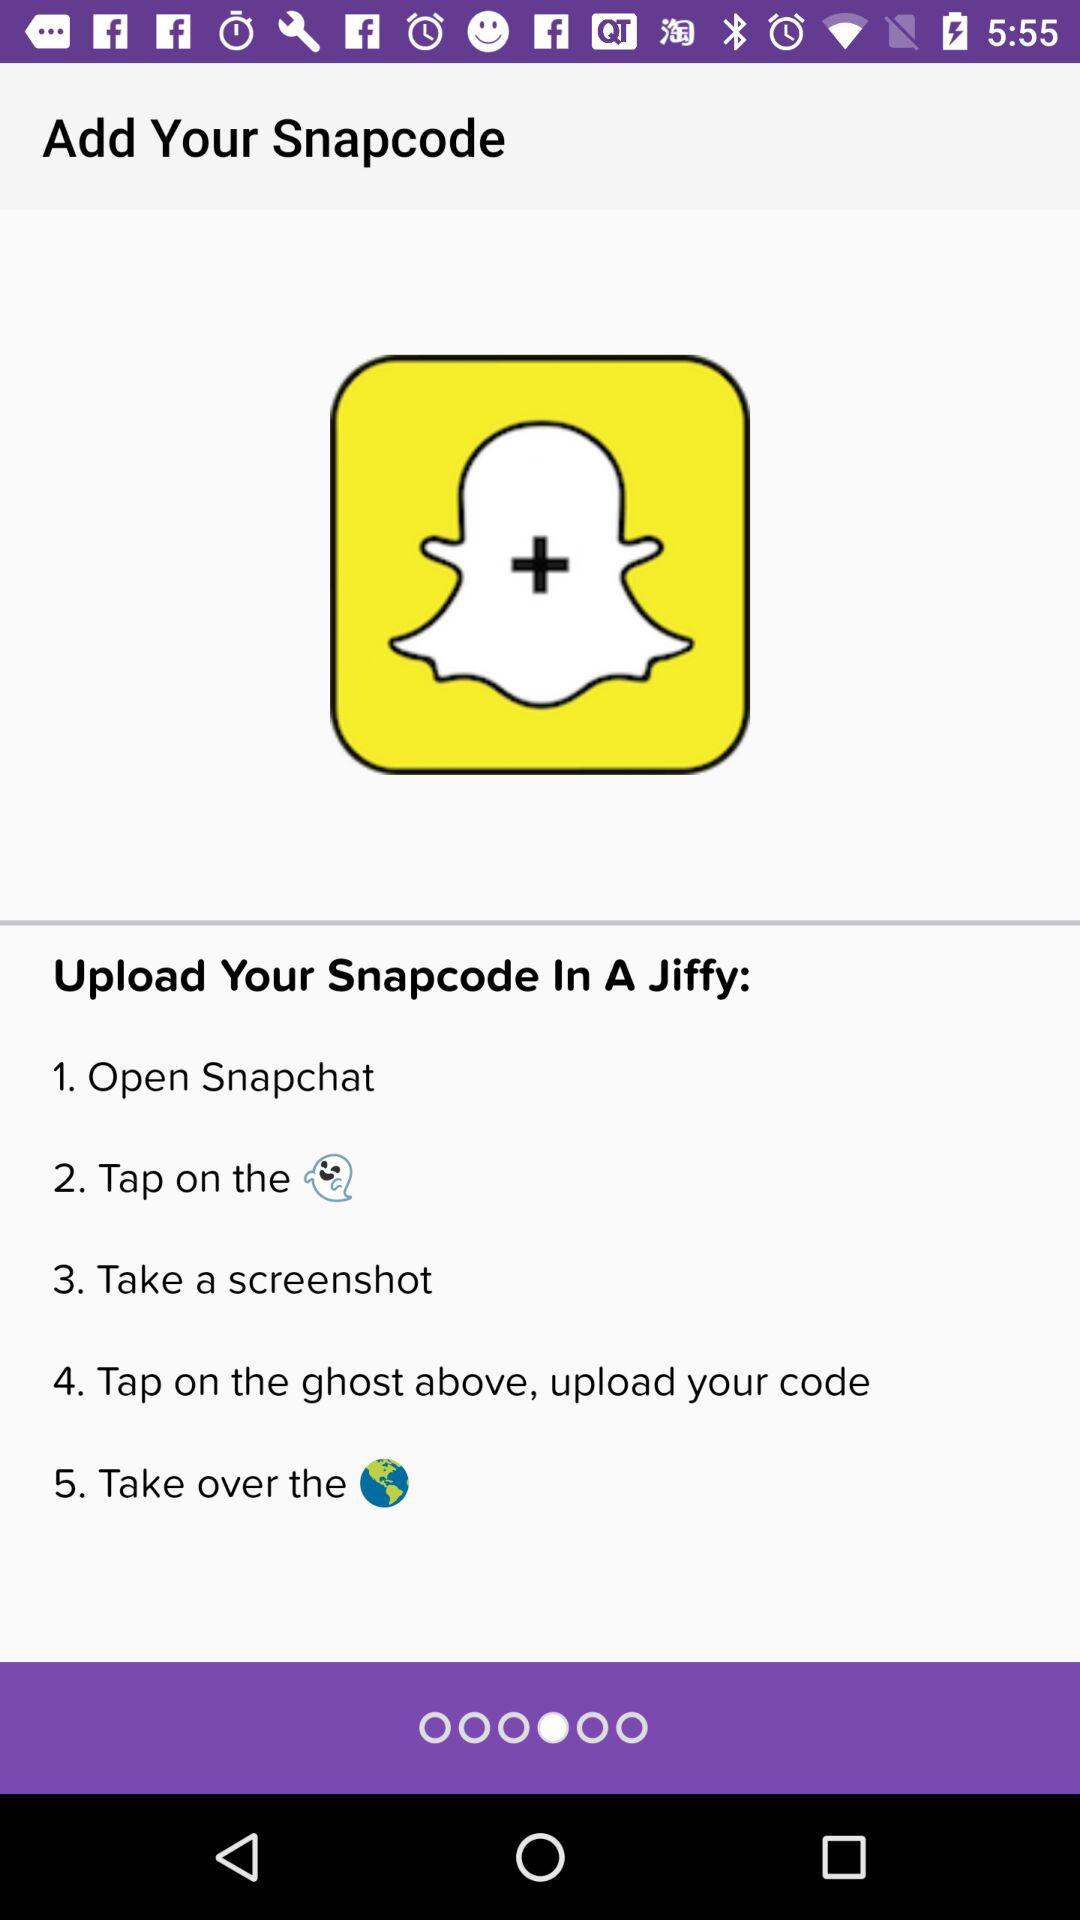Which code is the application asking to add?
When the provided information is insufficient, respond with <no answer>. <no answer> 